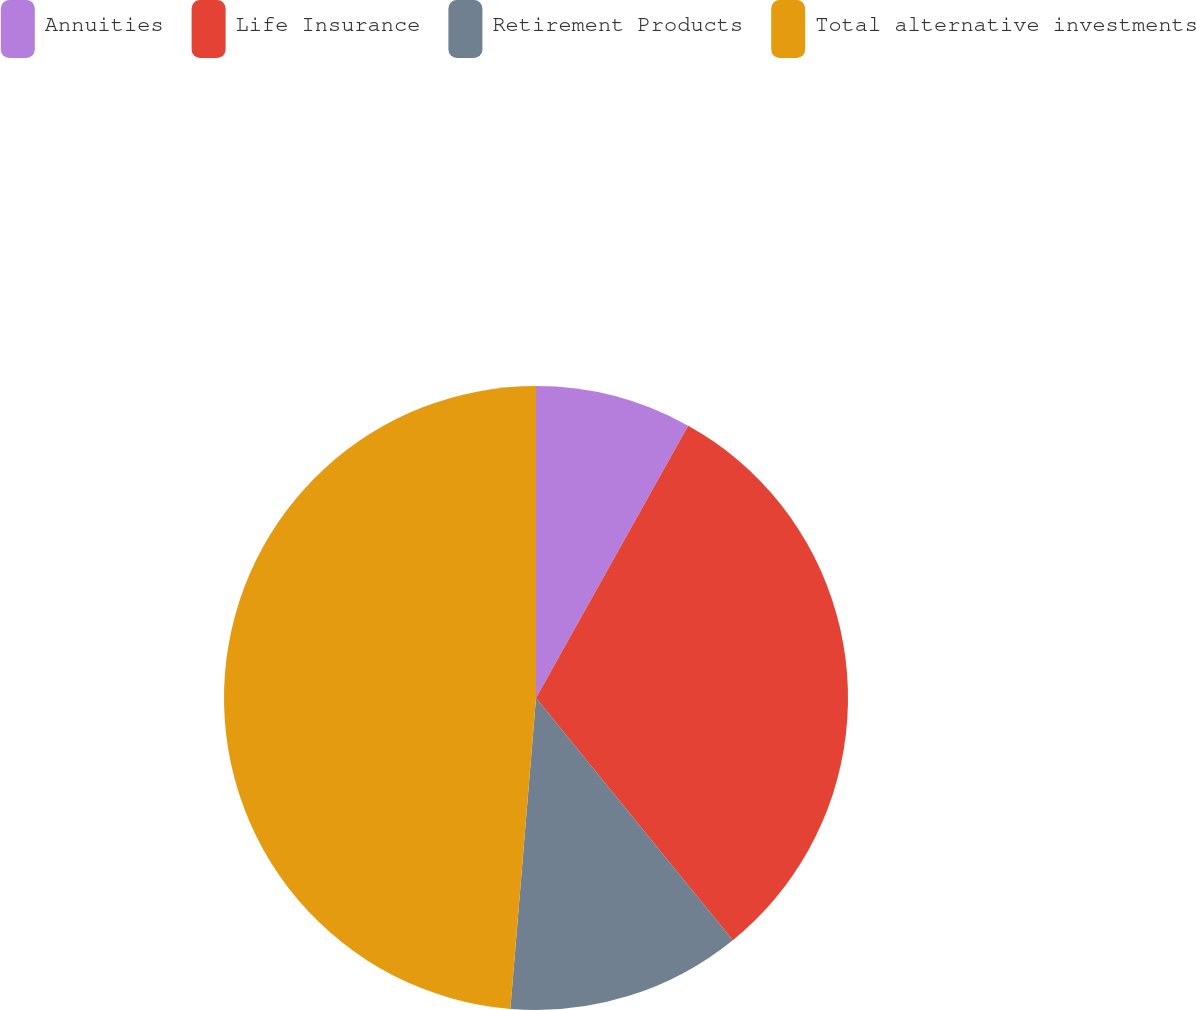Convert chart. <chart><loc_0><loc_0><loc_500><loc_500><pie_chart><fcel>Annuities<fcel>Life Insurance<fcel>Retirement Products<fcel>Total alternative investments<nl><fcel>8.11%<fcel>31.03%<fcel>12.17%<fcel>48.69%<nl></chart> 